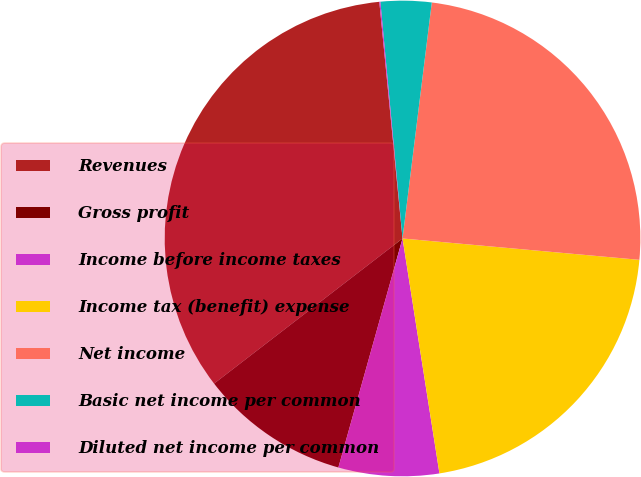<chart> <loc_0><loc_0><loc_500><loc_500><pie_chart><fcel>Revenues<fcel>Gross profit<fcel>Income before income taxes<fcel>Income tax (benefit) expense<fcel>Net income<fcel>Basic net income per common<fcel>Diluted net income per common<nl><fcel>33.89%<fcel>10.21%<fcel>6.83%<fcel>21.09%<fcel>24.47%<fcel>3.45%<fcel>0.07%<nl></chart> 